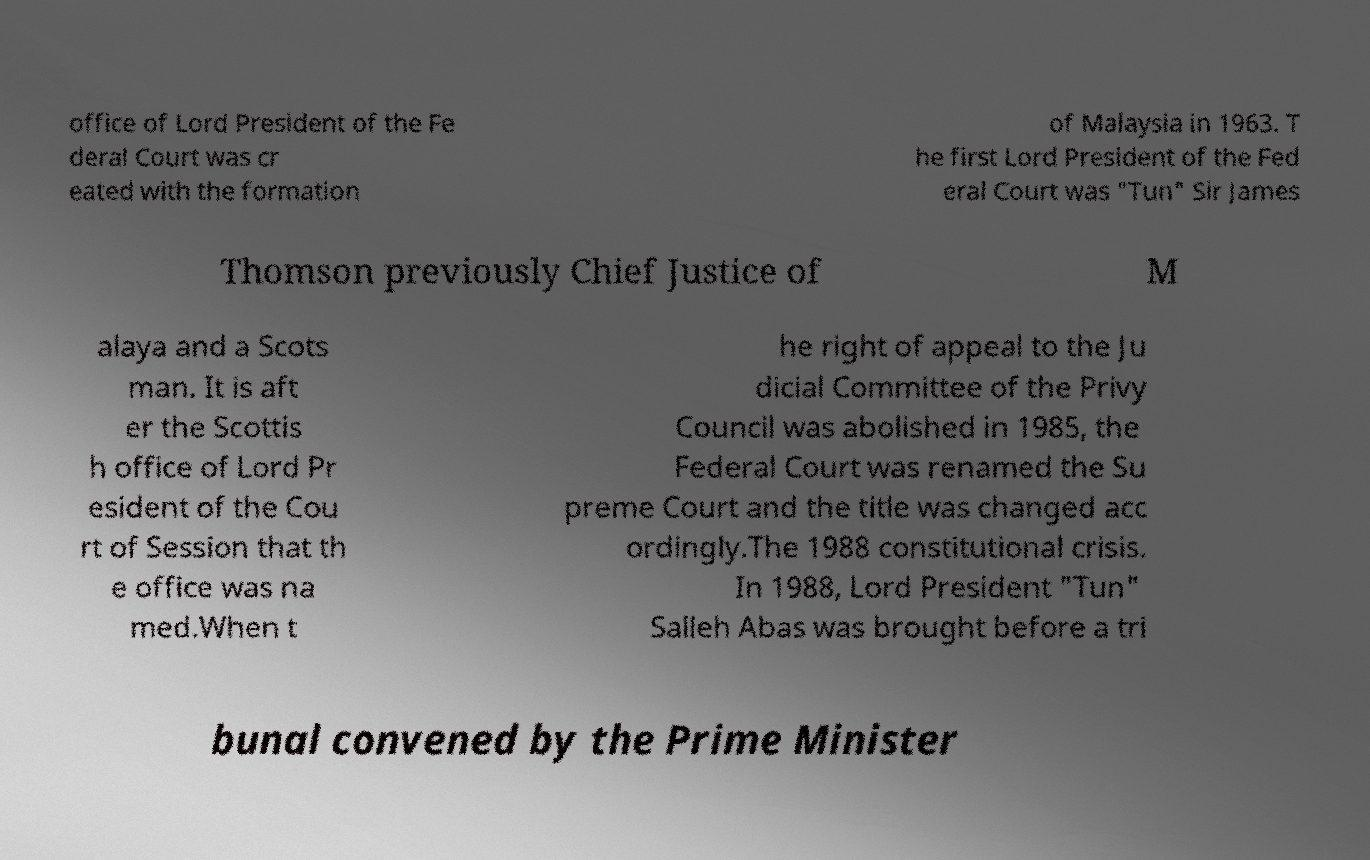I need the written content from this picture converted into text. Can you do that? office of Lord President of the Fe deral Court was cr eated with the formation of Malaysia in 1963. T he first Lord President of the Fed eral Court was "Tun" Sir James Thomson previously Chief Justice of M alaya and a Scots man. It is aft er the Scottis h office of Lord Pr esident of the Cou rt of Session that th e office was na med.When t he right of appeal to the Ju dicial Committee of the Privy Council was abolished in 1985, the Federal Court was renamed the Su preme Court and the title was changed acc ordingly.The 1988 constitutional crisis. In 1988, Lord President "Tun" Salleh Abas was brought before a tri bunal convened by the Prime Minister 